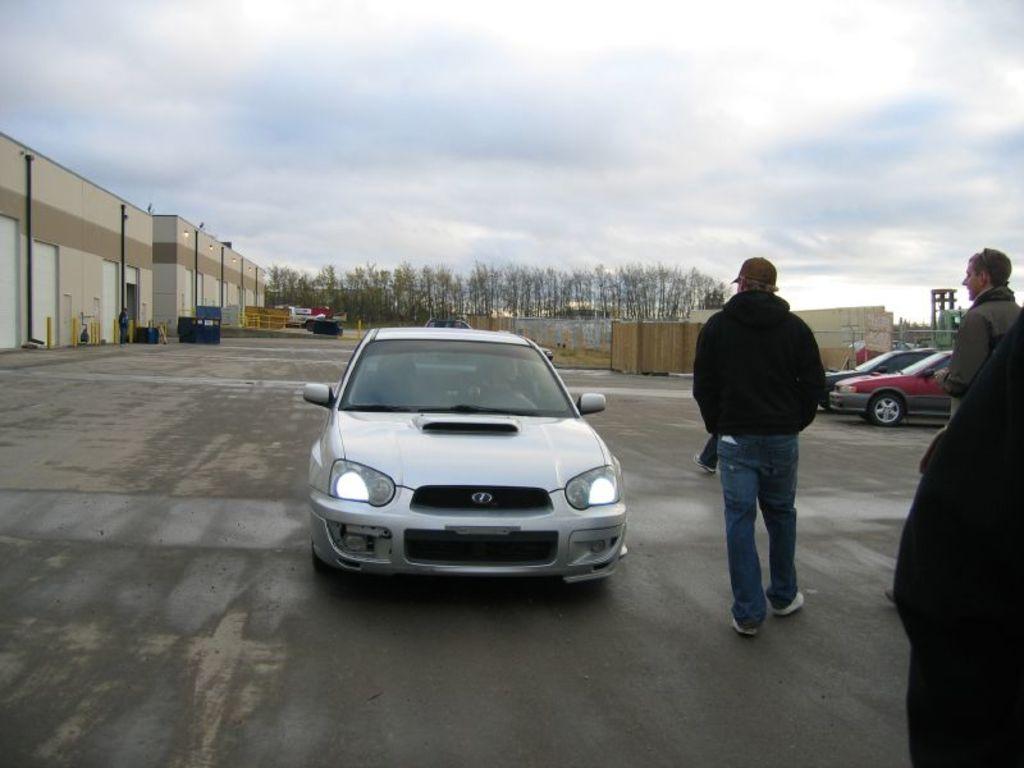Please provide a concise description of this image. In the image we can see there are vehicles, this is a footpath and there are people standing, wearing clothes, shoes and cap. We can even see there are many trees and cloudy sky. This is a building and lights. 